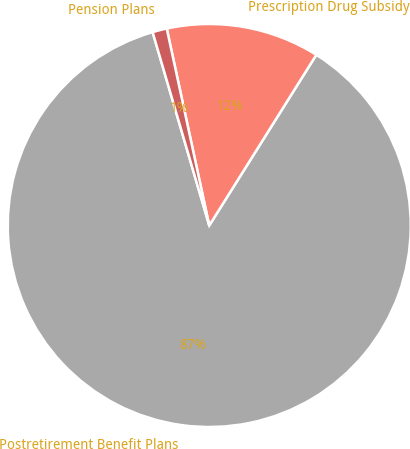<chart> <loc_0><loc_0><loc_500><loc_500><pie_chart><fcel>Postretirement Benefit Plans<fcel>Prescription Drug Subsidy<fcel>Pension Plans<nl><fcel>86.55%<fcel>12.3%<fcel>1.15%<nl></chart> 